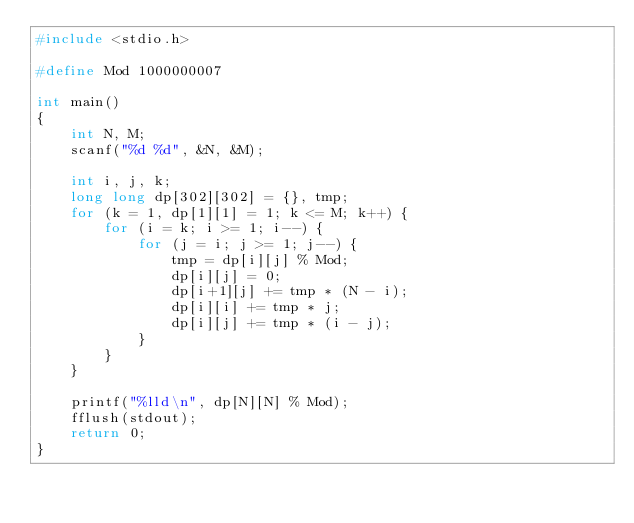Convert code to text. <code><loc_0><loc_0><loc_500><loc_500><_C_>#include <stdio.h>

#define Mod 1000000007

int main()
{	
	int N, M;
	scanf("%d %d", &N, &M);
	
	int i, j, k;
	long long dp[302][302] = {}, tmp;
	for (k = 1, dp[1][1] = 1; k <= M; k++) {
		for (i = k; i >= 1; i--) {
			for (j = i; j >= 1; j--) {
				tmp = dp[i][j] % Mod;
				dp[i][j] = 0;
				dp[i+1][j] += tmp * (N - i);
				dp[i][i] += tmp * j;
				dp[i][j] += tmp * (i - j);
			}
		}
	}
	
	printf("%lld\n", dp[N][N] % Mod);
	fflush(stdout);
	return 0;
}</code> 